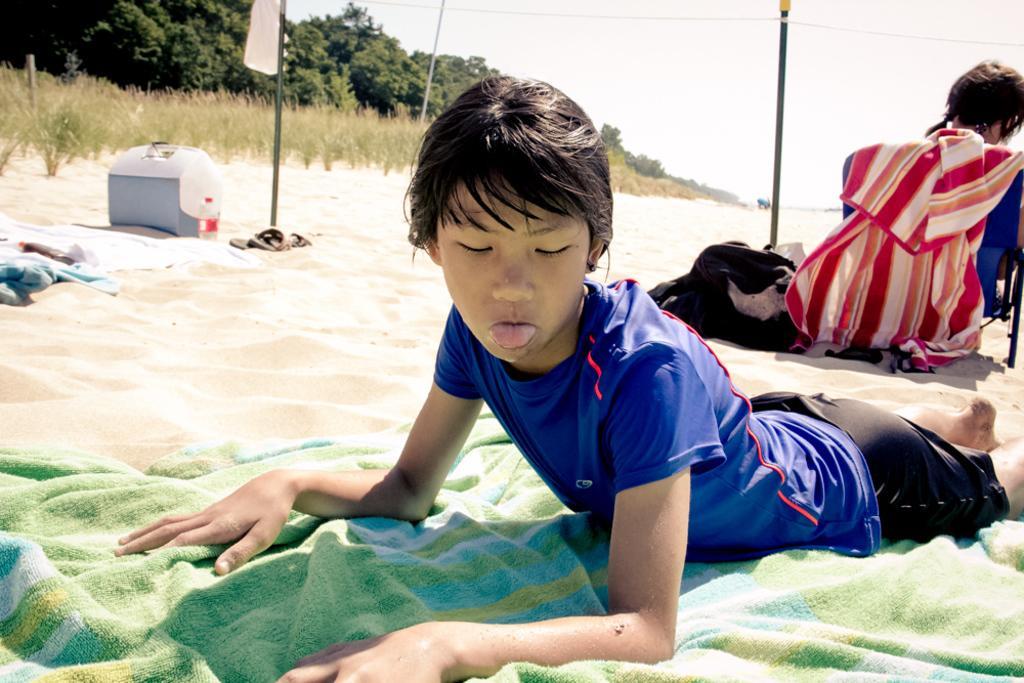In one or two sentences, can you explain what this image depicts? In this image there is a person laying on the towel , which is on the sand, and another person sitting on the chair, there are bags, bottles, sandals, cloth , box on the sand, and in the background there are trees, poles,sky. 